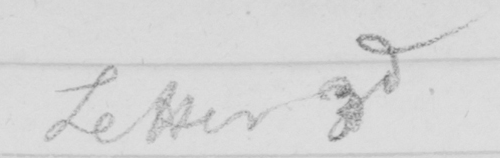Transcribe the text shown in this historical manuscript line. Letter 3rd 